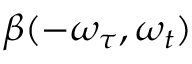Convert formula to latex. <formula><loc_0><loc_0><loc_500><loc_500>\beta ( - \omega _ { \tau } , \omega _ { t } )</formula> 